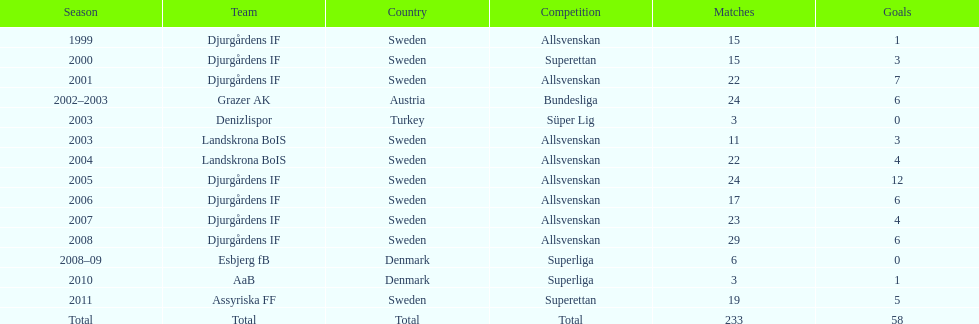Which nation does team djurgårdens if not originate from? Sweden. 